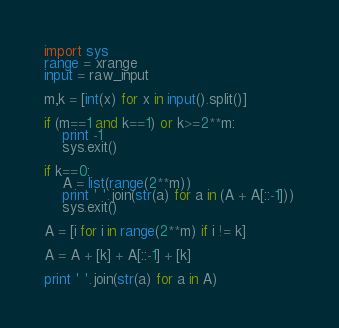Convert code to text. <code><loc_0><loc_0><loc_500><loc_500><_Python_>import sys
range = xrange
input = raw_input

m,k = [int(x) for x in input().split()]

if (m==1 and k==1) or k>=2**m:
    print -1
    sys.exit()

if k==0:
    A = list(range(2**m))
    print ' '.join(str(a) for a in (A + A[::-1]))
    sys.exit()

A = [i for i in range(2**m) if i != k]

A = A + [k] + A[::-1] + [k]

print ' '.join(str(a) for a in A)
</code> 